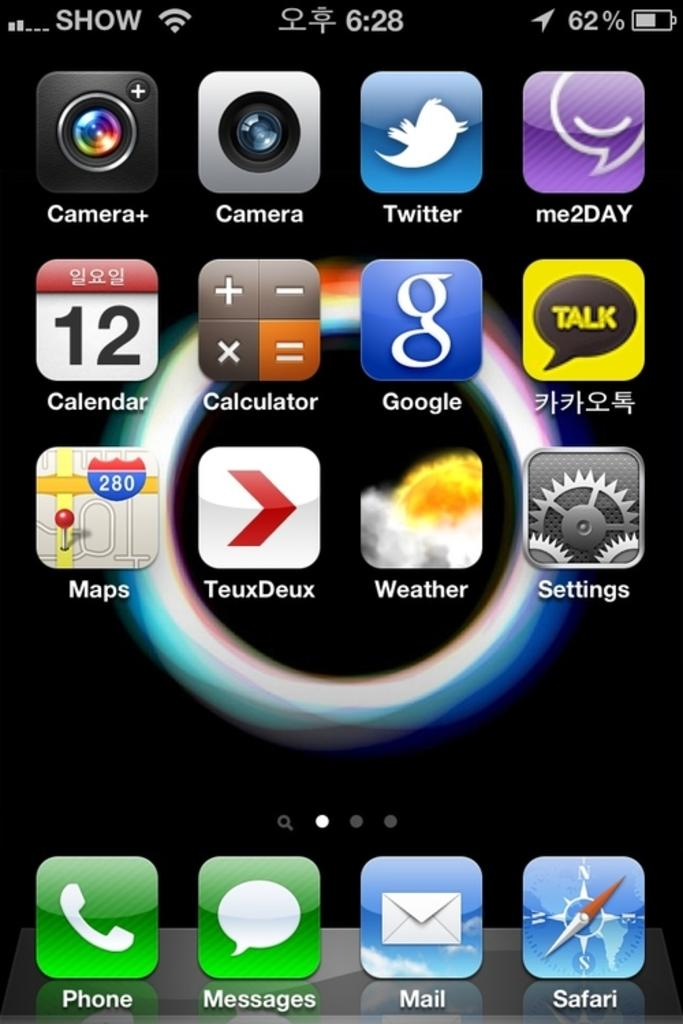Can you provide more specific information about the image? Unfortunately, I do not have any specific details about the image. How many pins are visible on the boys' clothing in the image? There is no information about boys or pins in the image, so it is not possible to answer that question. 